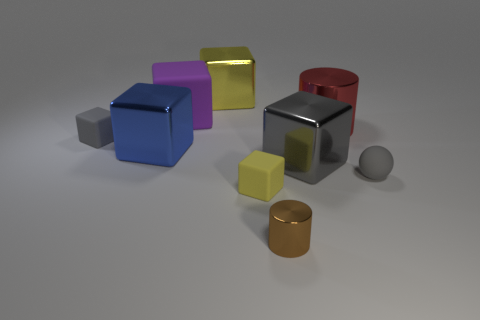Subtract 1 cubes. How many cubes are left? 5 Subtract all gray cubes. How many cubes are left? 4 Subtract all blue blocks. How many blocks are left? 5 Subtract all purple cubes. Subtract all gray cylinders. How many cubes are left? 5 Add 1 small metal cylinders. How many objects exist? 10 Subtract all spheres. How many objects are left? 8 Add 9 spheres. How many spheres exist? 10 Subtract 0 blue cylinders. How many objects are left? 9 Subtract all small yellow rubber blocks. Subtract all big red shiny cylinders. How many objects are left? 7 Add 6 blue objects. How many blue objects are left? 7 